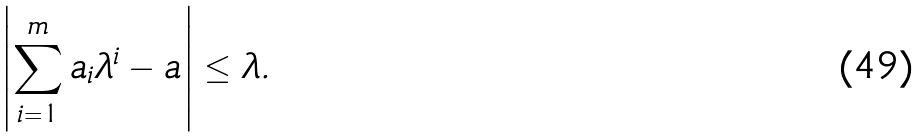Convert formula to latex. <formula><loc_0><loc_0><loc_500><loc_500>\left | \sum _ { i = 1 } ^ { m } a _ { i } \lambda ^ { i } - a \right | \leq \lambda .</formula> 